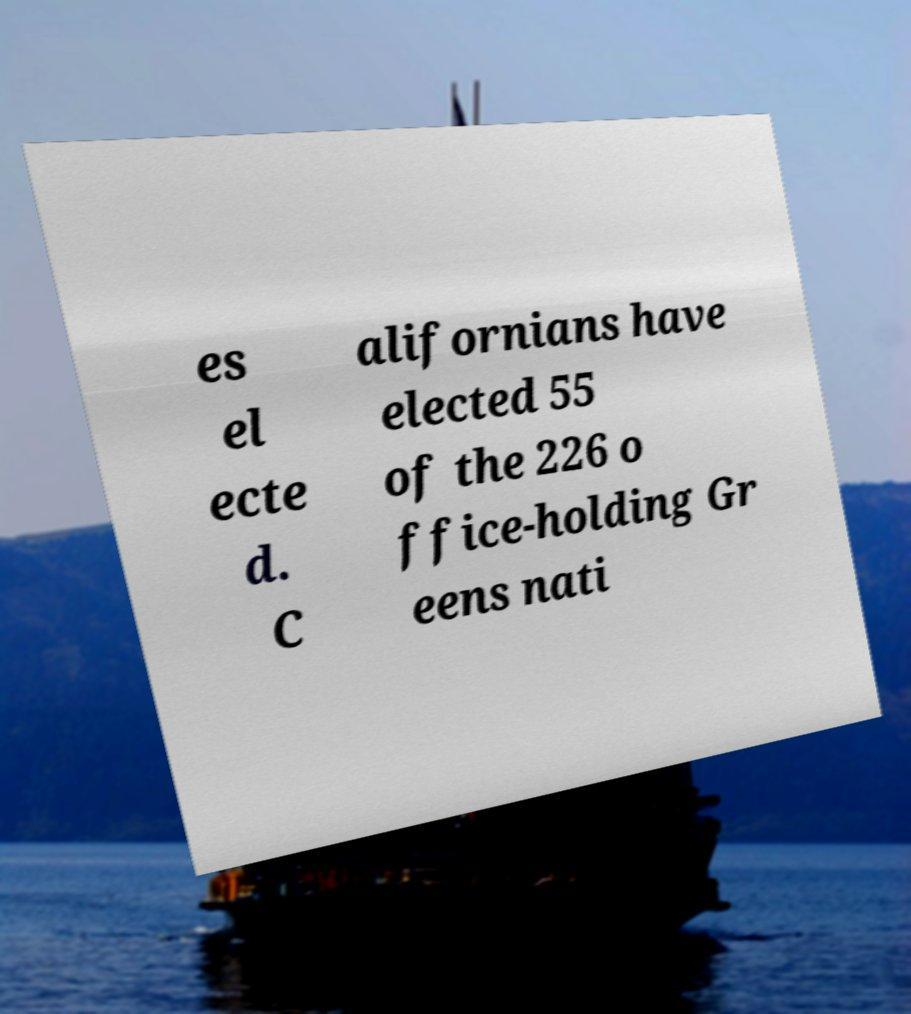What messages or text are displayed in this image? I need them in a readable, typed format. es el ecte d. C alifornians have elected 55 of the 226 o ffice-holding Gr eens nati 